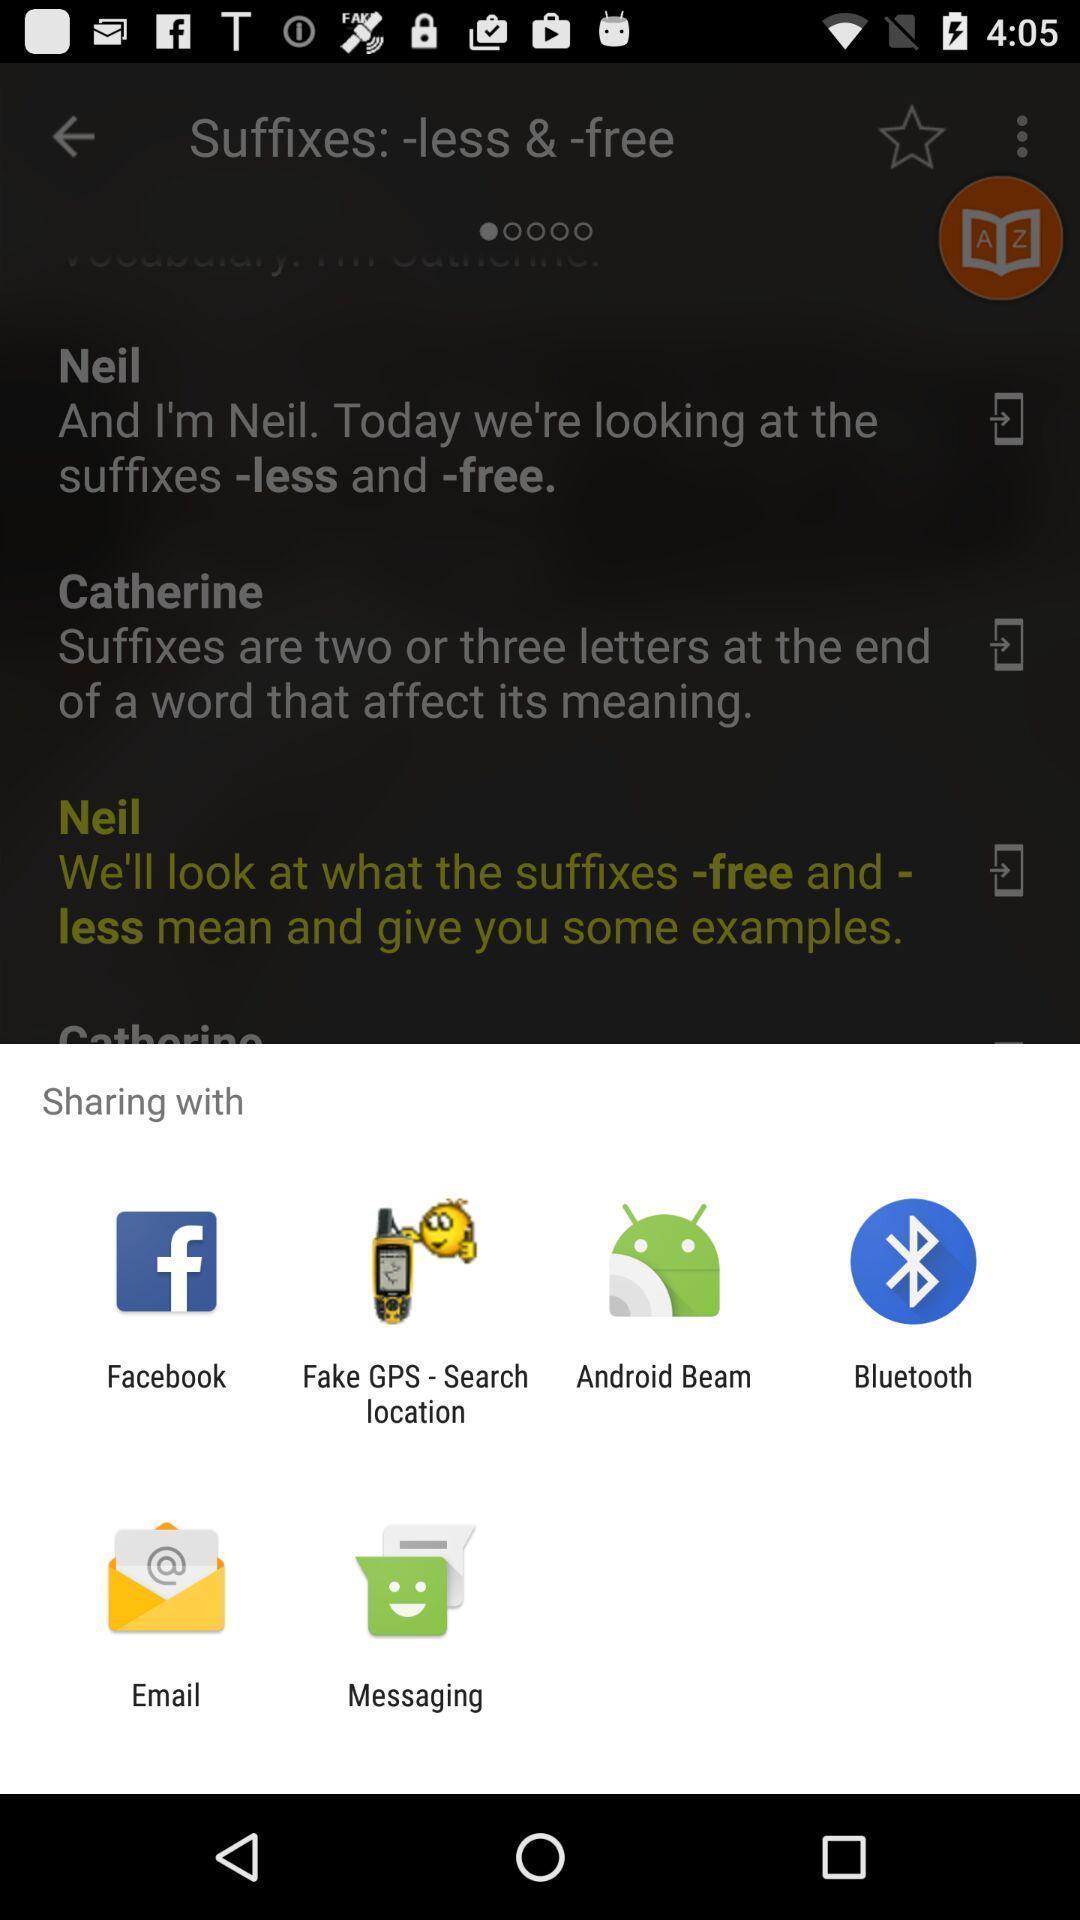Tell me about the visual elements in this screen capture. Popup page for sharing through different apps. 